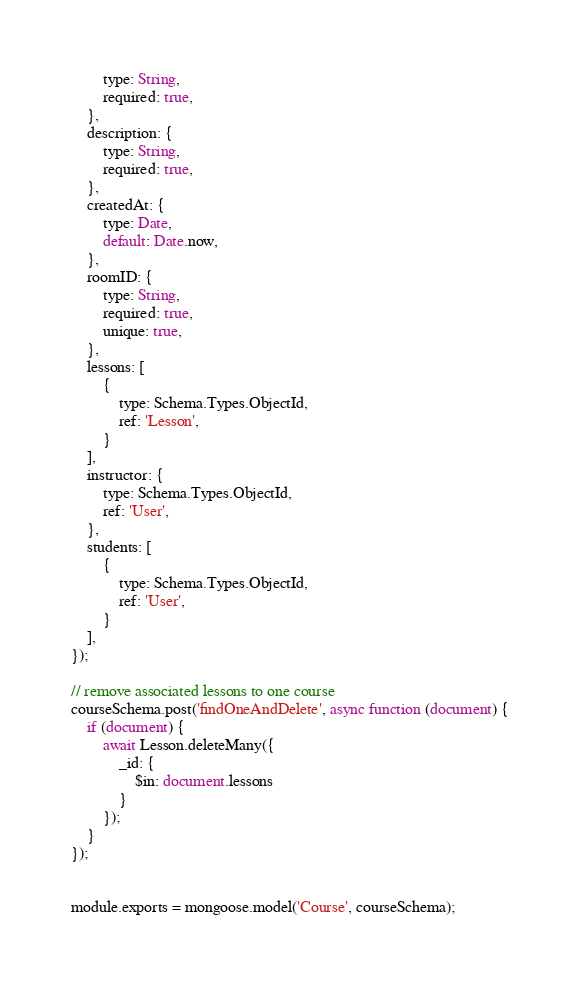<code> <loc_0><loc_0><loc_500><loc_500><_JavaScript_>        type: String,
        required: true,
    },
    description: {
        type: String,
        required: true,
    },
    createdAt: {
        type: Date,
        default: Date.now,
    },
    roomID: {
        type: String,
        required: true,
        unique: true,
    },
    lessons: [
        {
            type: Schema.Types.ObjectId,
            ref: 'Lesson',
        }
    ],
    instructor: {
        type: Schema.Types.ObjectId,
        ref: 'User',
    },
    students: [
        {
            type: Schema.Types.ObjectId,
            ref: 'User',
        }
    ],
});

// remove associated lessons to one course
courseSchema.post('findOneAndDelete', async function (document) {
    if (document) {
        await Lesson.deleteMany({
            _id: {
                $in: document.lessons
            }
        });
    }
});


module.exports = mongoose.model('Course', courseSchema);</code> 